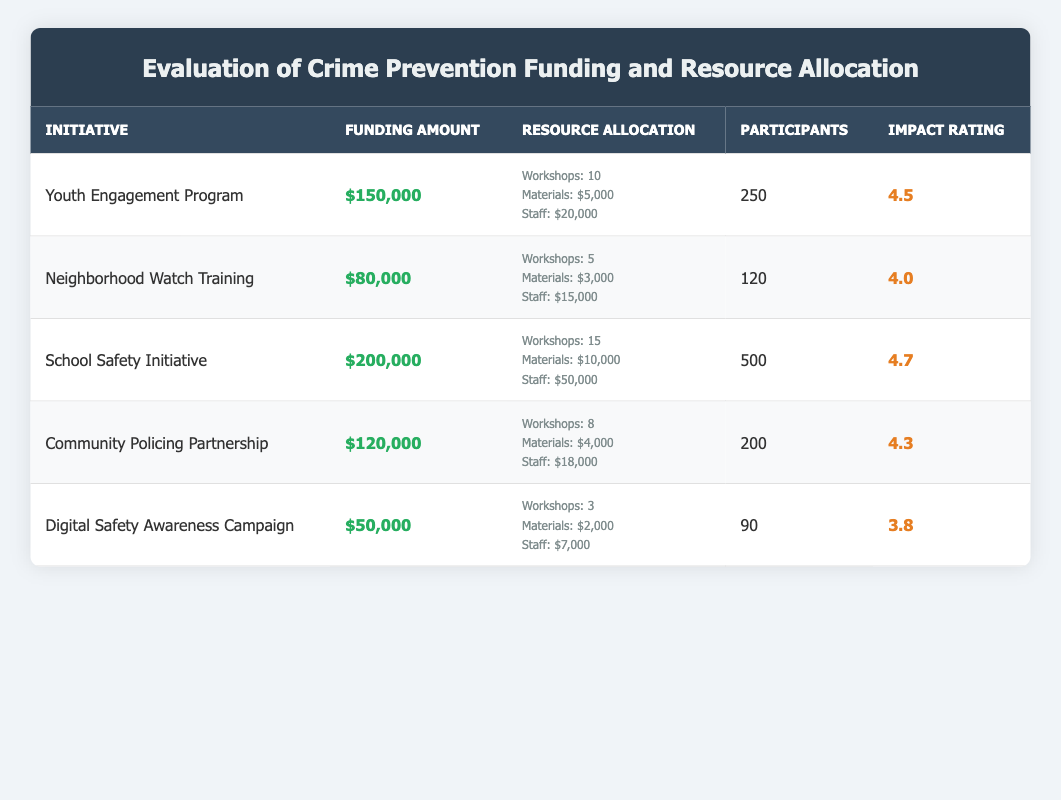What is the total funding allocated for the Youth Engagement Program? The table indicates that the funding amount for the Youth Engagement Program is listed as $150,000. Therefore, the answer is taken directly from the table.
Answer: $150,000 What is the average impact rating of all initiatives? To find the average impact rating, we need to sum the impact ratings: (4.5 + 4.0 + 4.7 + 4.3 + 3.8) = 21.3. Then, dividing by the number of initiatives (5) gives us an average of 21.3 / 5 = 4.26.
Answer: 4.26 Is the Neighborhood Watch Training initiative funded with more than $70,000? The funding amount for the Neighborhood Watch Training initiative is $80,000. Therefore, it exceeds $70,000.
Answer: Yes Which initiative had the highest number of participants? In the table, the School Safety Initiative is noted to have the highest number of participants at 500, exceeding all other listed initiatives.
Answer: School Safety Initiative What is the total funding allocated for initiatives that have an impact rating of 4.5 or greater? The initiatives with an impact rating of 4.5 or greater are the Youth Engagement Program, School Safety Initiative, and Community Policing Partnership. Their funding amounts are $150,000, $200,000, and $120,000 respectively. Summing these gives $150,000 + $200,000 + $120,000 = $470,000.
Answer: $470,000 How many workshops were conducted in total across all initiatives? The total number of workshops can be found by adding the workshops for each initiative: 10 (Youth Engagement Program) + 5 (Neighborhood Watch Training) + 15 (School Safety Initiative) + 8 (Community Policing Partnership) + 3 (Digital Safety Awareness Campaign) = 41 workshops in total.
Answer: 41 Is the impact rating of the Digital Safety Awareness Campaign higher than 4.0? The impact rating of the Digital Safety Awareness Campaign is 3.8, which is less than 4.0. Therefore, the answer is no.
Answer: No What is the total amount spent on staff for all initiatives? The table lists staff costs for each initiative: $20,000 (Youth Engagement Program), $15,000 (Neighborhood Watch Training), $50,000 (School Safety Initiative), $18,000 (Community Policing Partnership), and $7,000 (Digital Safety Awareness Campaign). Adding these gives: $20,000 + $15,000 + $50,000 + $18,000 + $7,000 = $110,000 total spent on staff.
Answer: $110,000 Which initiative utilized the least amount of funding? By comparing the funding amounts, the Digital Safety Awareness Campaign, with a funding amount of $50,000, is the lowest among all initiatives.
Answer: Digital Safety Awareness Campaign 